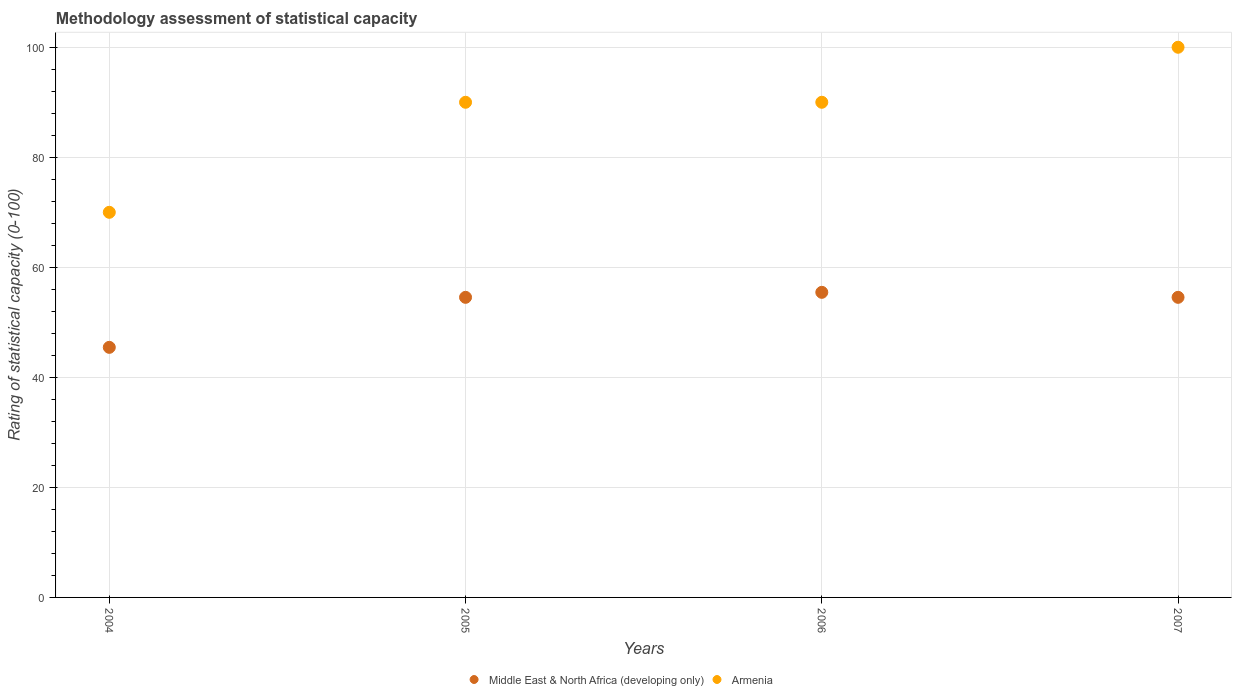What is the rating of statistical capacity in Middle East & North Africa (developing only) in 2006?
Your answer should be compact. 55.45. Across all years, what is the maximum rating of statistical capacity in Armenia?
Your answer should be very brief. 100. Across all years, what is the minimum rating of statistical capacity in Armenia?
Give a very brief answer. 70. What is the total rating of statistical capacity in Middle East & North Africa (developing only) in the graph?
Your answer should be very brief. 210. What is the difference between the rating of statistical capacity in Armenia in 2004 and that in 2006?
Make the answer very short. -20. What is the difference between the rating of statistical capacity in Armenia in 2006 and the rating of statistical capacity in Middle East & North Africa (developing only) in 2007?
Offer a terse response. 35.45. What is the average rating of statistical capacity in Armenia per year?
Offer a very short reply. 87.5. In the year 2006, what is the difference between the rating of statistical capacity in Armenia and rating of statistical capacity in Middle East & North Africa (developing only)?
Make the answer very short. 34.55. In how many years, is the rating of statistical capacity in Armenia greater than 4?
Give a very brief answer. 4. What is the ratio of the rating of statistical capacity in Middle East & North Africa (developing only) in 2004 to that in 2005?
Provide a succinct answer. 0.83. What is the difference between the highest and the second highest rating of statistical capacity in Middle East & North Africa (developing only)?
Your response must be concise. 0.91. Is the rating of statistical capacity in Middle East & North Africa (developing only) strictly less than the rating of statistical capacity in Armenia over the years?
Your response must be concise. Yes. What is the difference between two consecutive major ticks on the Y-axis?
Offer a terse response. 20. What is the title of the graph?
Your answer should be very brief. Methodology assessment of statistical capacity. What is the label or title of the X-axis?
Your response must be concise. Years. What is the label or title of the Y-axis?
Your response must be concise. Rating of statistical capacity (0-100). What is the Rating of statistical capacity (0-100) in Middle East & North Africa (developing only) in 2004?
Your answer should be very brief. 45.45. What is the Rating of statistical capacity (0-100) in Middle East & North Africa (developing only) in 2005?
Offer a very short reply. 54.55. What is the Rating of statistical capacity (0-100) of Armenia in 2005?
Keep it short and to the point. 90. What is the Rating of statistical capacity (0-100) of Middle East & North Africa (developing only) in 2006?
Your answer should be compact. 55.45. What is the Rating of statistical capacity (0-100) of Armenia in 2006?
Keep it short and to the point. 90. What is the Rating of statistical capacity (0-100) in Middle East & North Africa (developing only) in 2007?
Make the answer very short. 54.55. Across all years, what is the maximum Rating of statistical capacity (0-100) in Middle East & North Africa (developing only)?
Ensure brevity in your answer.  55.45. Across all years, what is the maximum Rating of statistical capacity (0-100) of Armenia?
Your answer should be compact. 100. Across all years, what is the minimum Rating of statistical capacity (0-100) of Middle East & North Africa (developing only)?
Keep it short and to the point. 45.45. Across all years, what is the minimum Rating of statistical capacity (0-100) of Armenia?
Your response must be concise. 70. What is the total Rating of statistical capacity (0-100) of Middle East & North Africa (developing only) in the graph?
Your response must be concise. 210. What is the total Rating of statistical capacity (0-100) in Armenia in the graph?
Your response must be concise. 350. What is the difference between the Rating of statistical capacity (0-100) in Middle East & North Africa (developing only) in 2004 and that in 2005?
Give a very brief answer. -9.09. What is the difference between the Rating of statistical capacity (0-100) of Armenia in 2004 and that in 2005?
Ensure brevity in your answer.  -20. What is the difference between the Rating of statistical capacity (0-100) of Middle East & North Africa (developing only) in 2004 and that in 2006?
Your answer should be compact. -10. What is the difference between the Rating of statistical capacity (0-100) in Armenia in 2004 and that in 2006?
Ensure brevity in your answer.  -20. What is the difference between the Rating of statistical capacity (0-100) of Middle East & North Africa (developing only) in 2004 and that in 2007?
Provide a succinct answer. -9.09. What is the difference between the Rating of statistical capacity (0-100) in Middle East & North Africa (developing only) in 2005 and that in 2006?
Your answer should be compact. -0.91. What is the difference between the Rating of statistical capacity (0-100) in Armenia in 2005 and that in 2007?
Your answer should be compact. -10. What is the difference between the Rating of statistical capacity (0-100) of Middle East & North Africa (developing only) in 2006 and that in 2007?
Ensure brevity in your answer.  0.91. What is the difference between the Rating of statistical capacity (0-100) in Armenia in 2006 and that in 2007?
Your answer should be very brief. -10. What is the difference between the Rating of statistical capacity (0-100) in Middle East & North Africa (developing only) in 2004 and the Rating of statistical capacity (0-100) in Armenia in 2005?
Your answer should be compact. -44.55. What is the difference between the Rating of statistical capacity (0-100) of Middle East & North Africa (developing only) in 2004 and the Rating of statistical capacity (0-100) of Armenia in 2006?
Give a very brief answer. -44.55. What is the difference between the Rating of statistical capacity (0-100) of Middle East & North Africa (developing only) in 2004 and the Rating of statistical capacity (0-100) of Armenia in 2007?
Ensure brevity in your answer.  -54.55. What is the difference between the Rating of statistical capacity (0-100) of Middle East & North Africa (developing only) in 2005 and the Rating of statistical capacity (0-100) of Armenia in 2006?
Make the answer very short. -35.45. What is the difference between the Rating of statistical capacity (0-100) of Middle East & North Africa (developing only) in 2005 and the Rating of statistical capacity (0-100) of Armenia in 2007?
Your answer should be very brief. -45.45. What is the difference between the Rating of statistical capacity (0-100) of Middle East & North Africa (developing only) in 2006 and the Rating of statistical capacity (0-100) of Armenia in 2007?
Your response must be concise. -44.55. What is the average Rating of statistical capacity (0-100) of Middle East & North Africa (developing only) per year?
Your response must be concise. 52.5. What is the average Rating of statistical capacity (0-100) in Armenia per year?
Provide a succinct answer. 87.5. In the year 2004, what is the difference between the Rating of statistical capacity (0-100) of Middle East & North Africa (developing only) and Rating of statistical capacity (0-100) of Armenia?
Your answer should be compact. -24.55. In the year 2005, what is the difference between the Rating of statistical capacity (0-100) of Middle East & North Africa (developing only) and Rating of statistical capacity (0-100) of Armenia?
Make the answer very short. -35.45. In the year 2006, what is the difference between the Rating of statistical capacity (0-100) in Middle East & North Africa (developing only) and Rating of statistical capacity (0-100) in Armenia?
Provide a succinct answer. -34.55. In the year 2007, what is the difference between the Rating of statistical capacity (0-100) of Middle East & North Africa (developing only) and Rating of statistical capacity (0-100) of Armenia?
Your answer should be compact. -45.45. What is the ratio of the Rating of statistical capacity (0-100) of Middle East & North Africa (developing only) in 2004 to that in 2005?
Make the answer very short. 0.83. What is the ratio of the Rating of statistical capacity (0-100) of Armenia in 2004 to that in 2005?
Your answer should be compact. 0.78. What is the ratio of the Rating of statistical capacity (0-100) of Middle East & North Africa (developing only) in 2004 to that in 2006?
Ensure brevity in your answer.  0.82. What is the ratio of the Rating of statistical capacity (0-100) of Middle East & North Africa (developing only) in 2005 to that in 2006?
Offer a terse response. 0.98. What is the ratio of the Rating of statistical capacity (0-100) in Armenia in 2005 to that in 2006?
Ensure brevity in your answer.  1. What is the ratio of the Rating of statistical capacity (0-100) of Middle East & North Africa (developing only) in 2005 to that in 2007?
Your answer should be very brief. 1. What is the ratio of the Rating of statistical capacity (0-100) in Middle East & North Africa (developing only) in 2006 to that in 2007?
Your answer should be very brief. 1.02. What is the difference between the highest and the lowest Rating of statistical capacity (0-100) in Middle East & North Africa (developing only)?
Offer a very short reply. 10. 